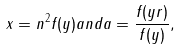Convert formula to latex. <formula><loc_0><loc_0><loc_500><loc_500>x = n ^ { 2 } f ( y ) a n d a = \frac { f ( y r ) } { f ( y ) } ,</formula> 